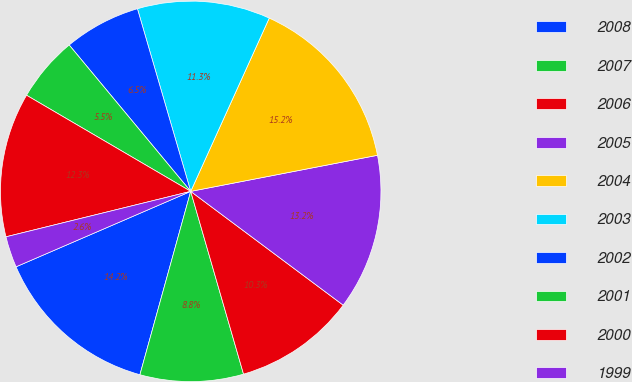<chart> <loc_0><loc_0><loc_500><loc_500><pie_chart><fcel>2008<fcel>2007<fcel>2006<fcel>2005<fcel>2004<fcel>2003<fcel>2002<fcel>2001<fcel>2000<fcel>1999<nl><fcel>14.21%<fcel>8.78%<fcel>10.32%<fcel>13.24%<fcel>15.19%<fcel>11.29%<fcel>6.51%<fcel>5.54%<fcel>12.27%<fcel>2.65%<nl></chart> 